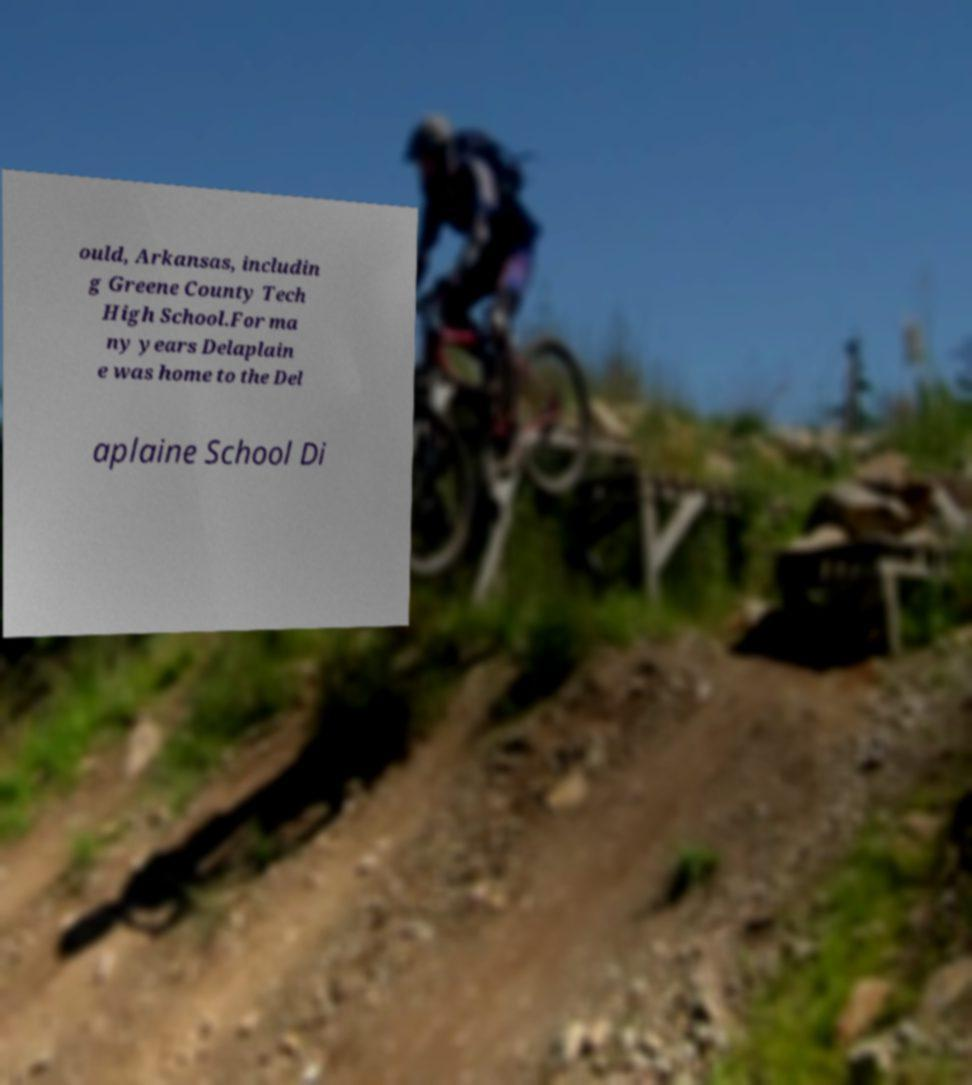I need the written content from this picture converted into text. Can you do that? ould, Arkansas, includin g Greene County Tech High School.For ma ny years Delaplain e was home to the Del aplaine School Di 